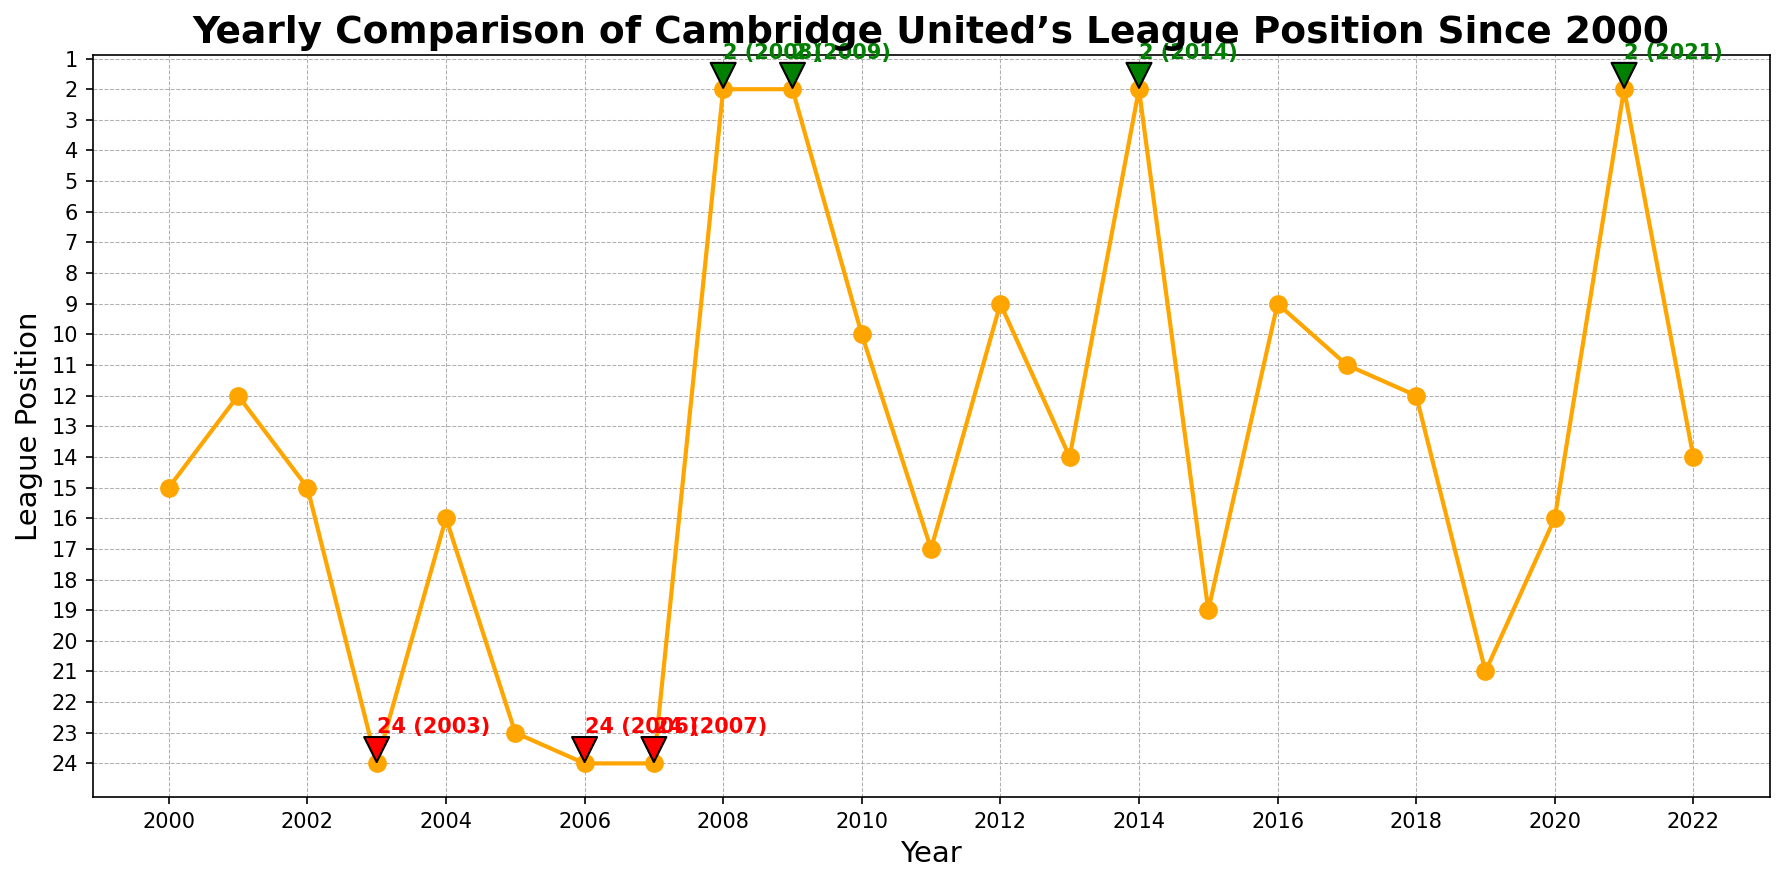What was Cambridge United’s best league position, and in which years did this occur? The lowest point on the line chart represents the best league position. The best position is 2, which occurred in 2008, 2009, 2014, and 2021.
Answer: 2 in 2008, 2009, 2014, 2021 In how many years did Cambridge United finish in the relegation zone? The line chart indicates that a position of 24 is in the relegation zone. Cambridge United finished in the relegation zone in 2003, 2006, and 2007.
Answer: 3 years Which year did Cambridge United experience its biggest improvement in league position compared to the previous year? By comparing the consecutive yearly positions on the line chart, the largest drop (improvement) occurred between 2007 (24) and 2008 (2). That's a change of 22 positions.
Answer: 2008 What are the trends observed in Cambridge United's league position from 2000 to 2022? The line chart shows fluctuations, with significant dips indicating relegation (2003, 2006, 2007) and peaks indicating promotion (2008, 2009, 2014, 2021).
Answer: Fluctuating Which period had the most stable league performance in terms of positions? By observing the line chart, the period from 2016 to 2018 shows minimal changes in position, staying within the 9-12 range.
Answer: 2016-2018 Did Cambridge United experience more promotions or relegations based on the chart? Promotion years are marked with a green annotation (positions of 2), and relegation years are marked with a red annotation (positions of 24). There are four promotions and three relegations.
Answer: More promotions What is the average league position of Cambridge United from 2000 to 2022? Calculate the mean position by adding all yearly positions and dividing by the number of years. Sum = 15 + 12 + 15 + 24 + 16 + 23 + 24 + 24 + 2 + 2 + 10 + 17 + 9 + 14 + 2 + 19 + 9 + 11 + 12 + 21 + 16 + 2 + 14 = 299; there are 23 years, so average = 299 / 23 ≈ 13.
Answer: 13 In which periods did Cambridge United manage to avoid finishing in the bottom 10 positions continuously for at least five years? By scanning the chart, from 2012 to 2016, Cambridge United did not drop below the 14th position for five consecutive years.
Answer: 2012-2016 Which year saw Cambridge United’s league position worsen the most compared to the previous year? Comparing consecutive years, the largest increase (worsening) in position occurred between 2004 (16) and 2005 (23), a change of 7 positions.
Answer: 2005 What notable pattern do you see in terms of promotion and relegation annotations on the chart? The chart shows that promotions (green) tend to follow periods of low performance (high positions), while relegations (red) tend to follow periods of better performance (lower positions).
Answer: Promotions follow lows; relegations follow highs 